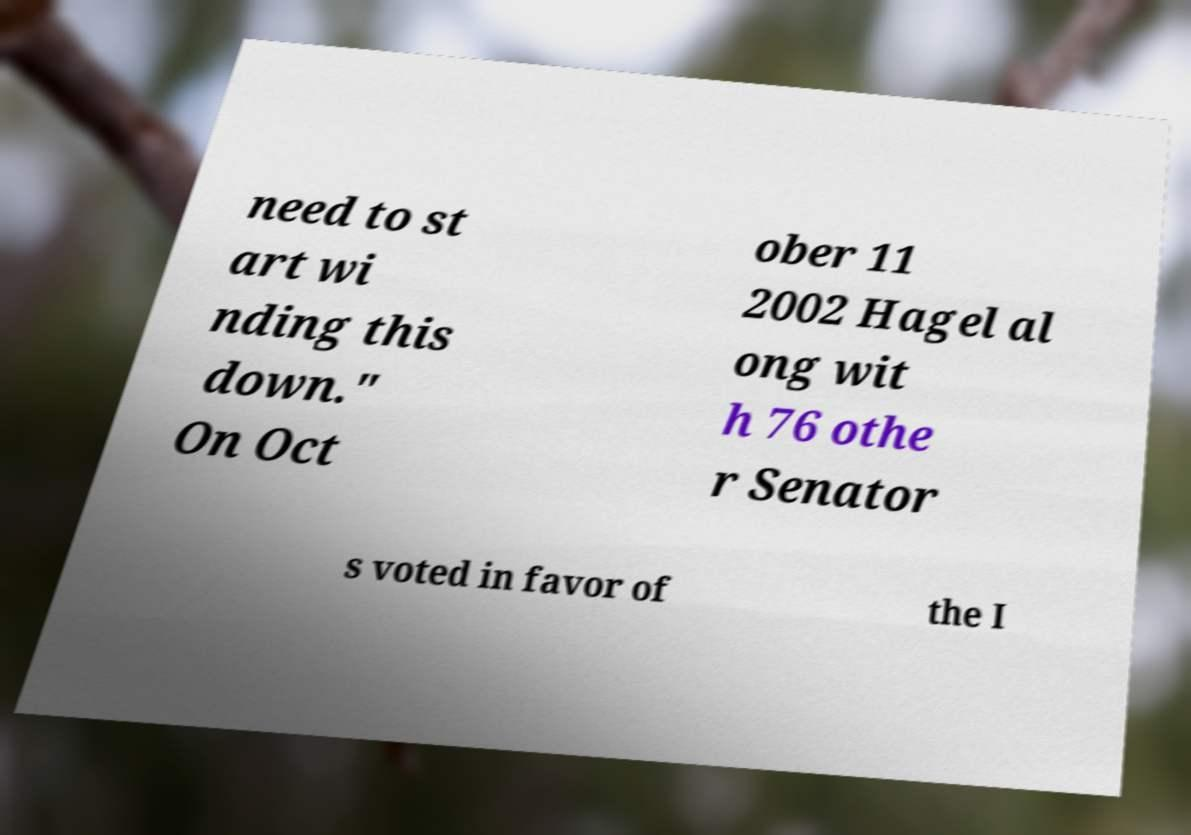Can you accurately transcribe the text from the provided image for me? need to st art wi nding this down." On Oct ober 11 2002 Hagel al ong wit h 76 othe r Senator s voted in favor of the I 